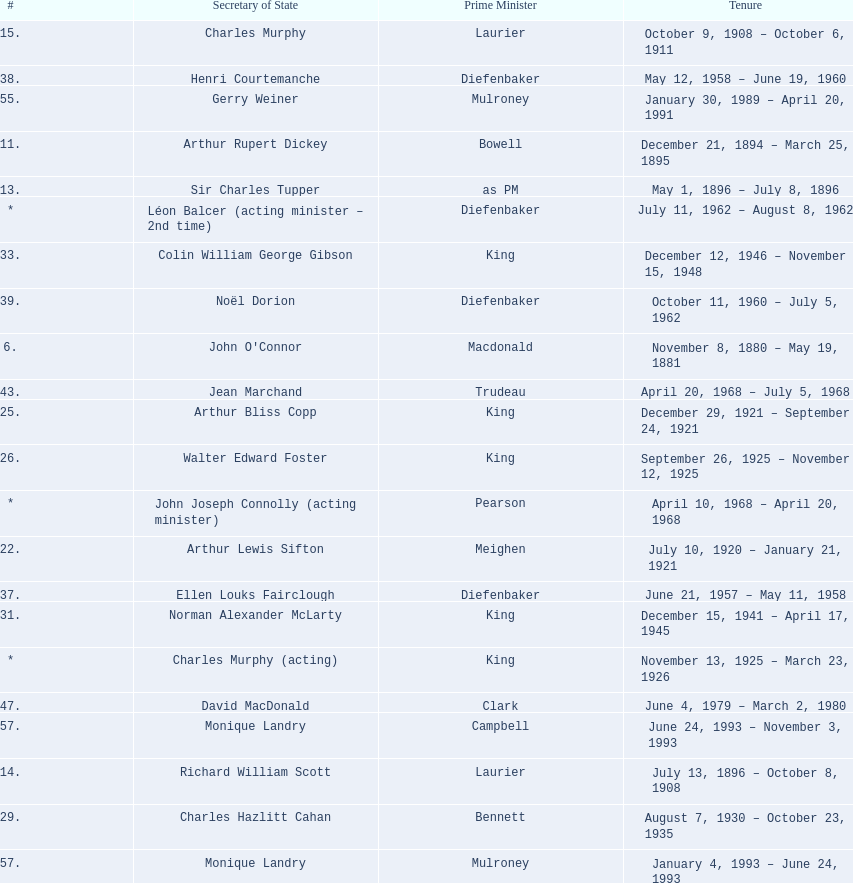Who was thompson's secretary of state? John Costigan. 